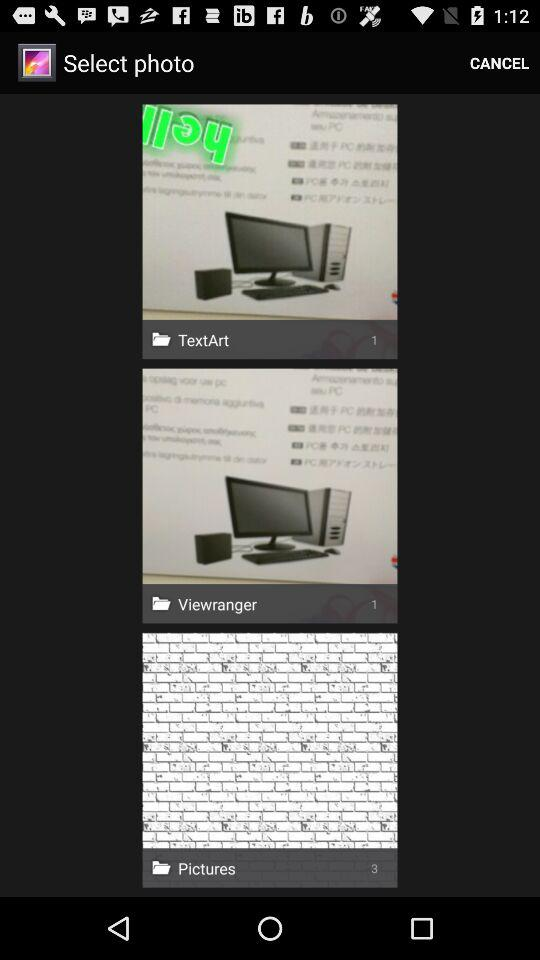How many photos are in the "TextArt" folder? There is only 1 photo in the "TextArt" folder. 